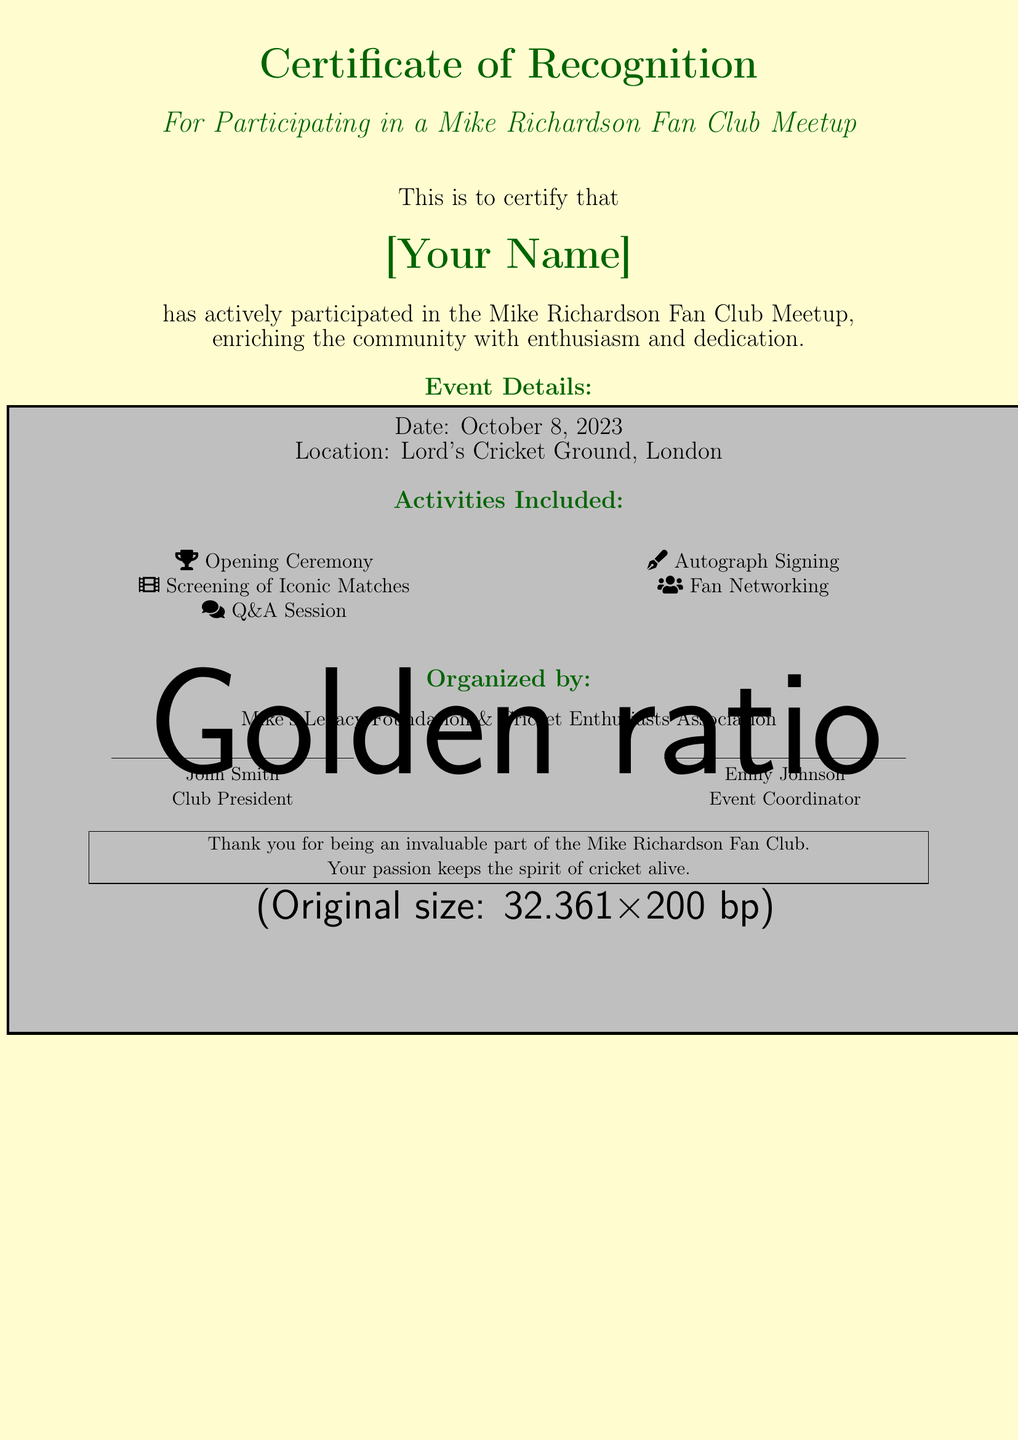what is the title of the document? The title of the document is presented in the header of the certificate.
Answer: Certificate of Recognition who is the recipient of the certificate? The recipient's name is indicated on the certificate in a separate prominent section.
Answer: [Your Name] what is the date of the event? The date of the event is mentioned in the event details section of the certificate.
Answer: October 8, 2023 where was the event held? The location is clearly stated in the event details section of the certificate.
Answer: Lord's Cricket Ground, London what activities were included in the meetup? The activities are listed in a specific section devoted to describing the event's highlights.
Answer: Opening Ceremony, Screening of Iconic Matches, Q&A Session, Autograph Signing, Fan Networking who organized the event? The organizing entities are presented in a dedicated section of the certificate.
Answer: Mike's Legacy Foundation & Cricket Enthusiasts Association who signed the certificate as Club President? The signature section identifies the person in the role of Club President.
Answer: John Smith what does the certificate thank the recipient for? The thank-you note in the certificate acknowledges the recipient's contribution.
Answer: being an invaluable part of the Mike Richardson Fan Club 